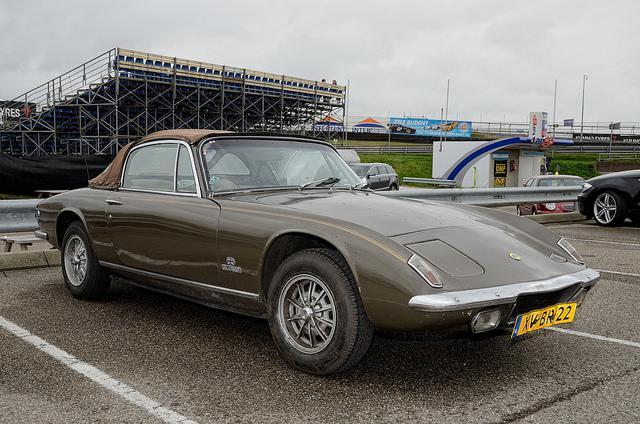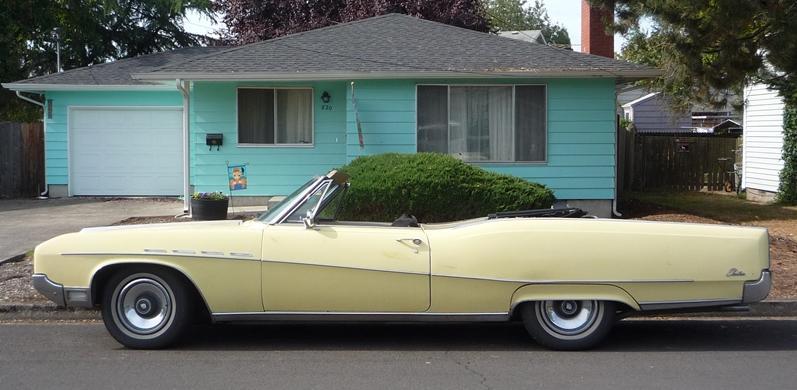The first image is the image on the left, the second image is the image on the right. Given the left and right images, does the statement "One image shows a blue convertible with the top down." hold true? Answer yes or no. No. 